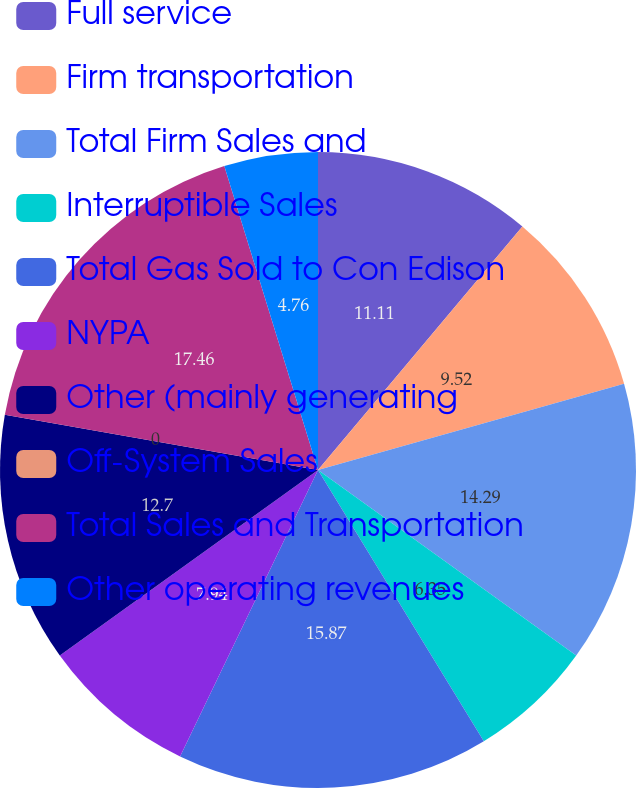Convert chart. <chart><loc_0><loc_0><loc_500><loc_500><pie_chart><fcel>Full service<fcel>Firm transportation<fcel>Total Firm Sales and<fcel>Interruptible Sales<fcel>Total Gas Sold to Con Edison<fcel>NYPA<fcel>Other (mainly generating<fcel>Off-System Sales<fcel>Total Sales and Transportation<fcel>Other operating revenues<nl><fcel>11.11%<fcel>9.52%<fcel>14.29%<fcel>6.35%<fcel>15.87%<fcel>7.94%<fcel>12.7%<fcel>0.0%<fcel>17.46%<fcel>4.76%<nl></chart> 